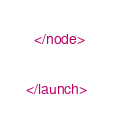Convert code to text. <code><loc_0><loc_0><loc_500><loc_500><_XML_>  </node>

</launch>
</code> 